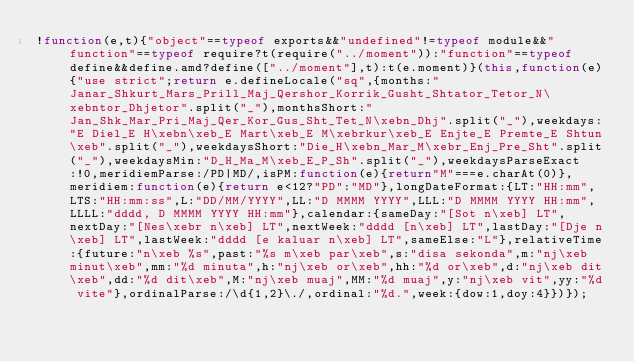<code> <loc_0><loc_0><loc_500><loc_500><_JavaScript_>!function(e,t){"object"==typeof exports&&"undefined"!=typeof module&&"function"==typeof require?t(require("../moment")):"function"==typeof define&&define.amd?define(["../moment"],t):t(e.moment)}(this,function(e){"use strict";return e.defineLocale("sq",{months:"Janar_Shkurt_Mars_Prill_Maj_Qershor_Korrik_Gusht_Shtator_Tetor_N\xebntor_Dhjetor".split("_"),monthsShort:"Jan_Shk_Mar_Pri_Maj_Qer_Kor_Gus_Sht_Tet_N\xebn_Dhj".split("_"),weekdays:"E Diel_E H\xebn\xeb_E Mart\xeb_E M\xebrkur\xeb_E Enjte_E Premte_E Shtun\xeb".split("_"),weekdaysShort:"Die_H\xebn_Mar_M\xebr_Enj_Pre_Sht".split("_"),weekdaysMin:"D_H_Ma_M\xeb_E_P_Sh".split("_"),weekdaysParseExact:!0,meridiemParse:/PD|MD/,isPM:function(e){return"M"===e.charAt(0)},meridiem:function(e){return e<12?"PD":"MD"},longDateFormat:{LT:"HH:mm",LTS:"HH:mm:ss",L:"DD/MM/YYYY",LL:"D MMMM YYYY",LLL:"D MMMM YYYY HH:mm",LLLL:"dddd, D MMMM YYYY HH:mm"},calendar:{sameDay:"[Sot n\xeb] LT",nextDay:"[Nes\xebr n\xeb] LT",nextWeek:"dddd [n\xeb] LT",lastDay:"[Dje n\xeb] LT",lastWeek:"dddd [e kaluar n\xeb] LT",sameElse:"L"},relativeTime:{future:"n\xeb %s",past:"%s m\xeb par\xeb",s:"disa sekonda",m:"nj\xeb minut\xeb",mm:"%d minuta",h:"nj\xeb or\xeb",hh:"%d or\xeb",d:"nj\xeb dit\xeb",dd:"%d dit\xeb",M:"nj\xeb muaj",MM:"%d muaj",y:"nj\xeb vit",yy:"%d vite"},ordinalParse:/\d{1,2}\./,ordinal:"%d.",week:{dow:1,doy:4}})});</code> 